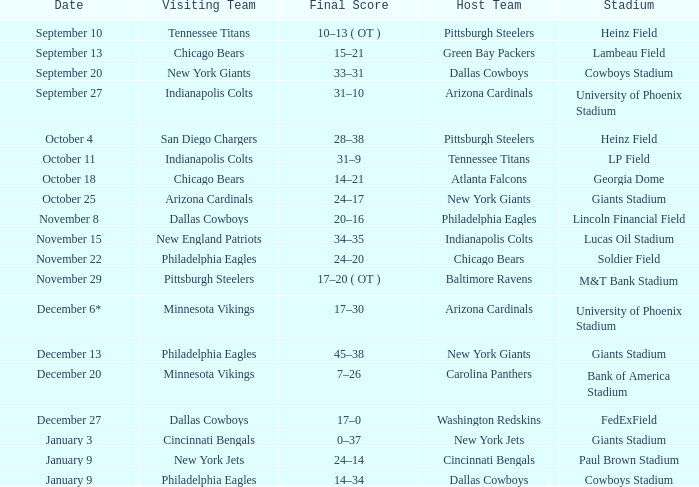I want to know the final score for december 27 17–0. 